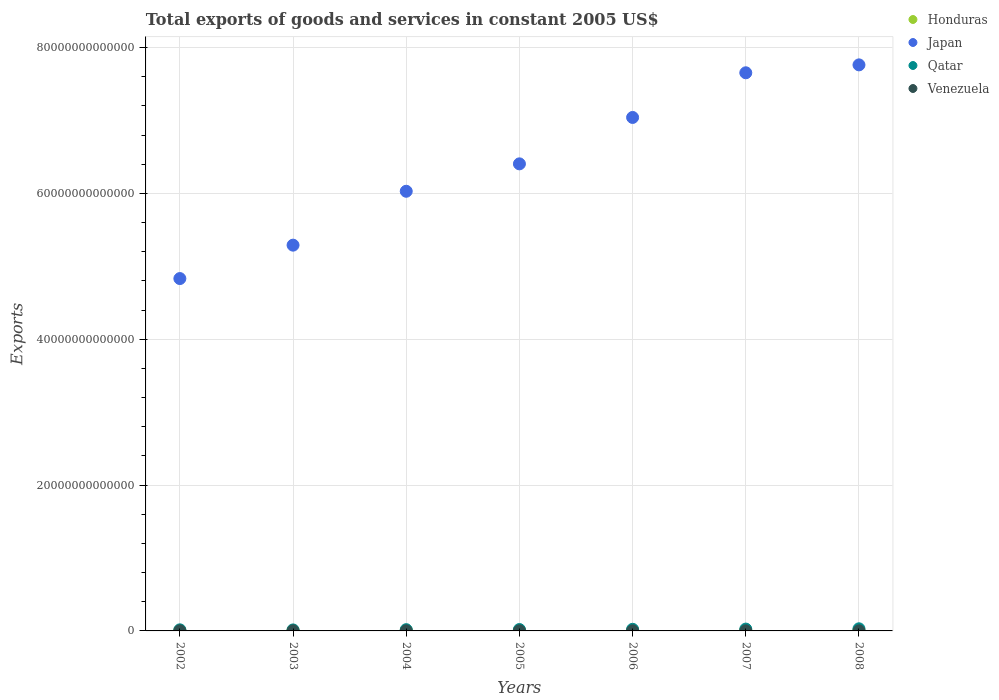What is the total exports of goods and services in Qatar in 2004?
Offer a very short reply. 1.72e+11. Across all years, what is the maximum total exports of goods and services in Japan?
Offer a very short reply. 7.76e+13. Across all years, what is the minimum total exports of goods and services in Honduras?
Keep it short and to the point. 6.58e+1. In which year was the total exports of goods and services in Qatar maximum?
Offer a very short reply. 2008. In which year was the total exports of goods and services in Honduras minimum?
Provide a short and direct response. 2002. What is the total total exports of goods and services in Qatar in the graph?
Your answer should be compact. 1.41e+12. What is the difference between the total exports of goods and services in Qatar in 2005 and that in 2006?
Your response must be concise. -3.11e+1. What is the difference between the total exports of goods and services in Qatar in 2005 and the total exports of goods and services in Venezuela in 2007?
Keep it short and to the point. 1.80e+11. What is the average total exports of goods and services in Qatar per year?
Make the answer very short. 2.02e+11. In the year 2006, what is the difference between the total exports of goods and services in Venezuela and total exports of goods and services in Japan?
Make the answer very short. -7.04e+13. What is the ratio of the total exports of goods and services in Venezuela in 2002 to that in 2005?
Keep it short and to the point. 0.95. What is the difference between the highest and the second highest total exports of goods and services in Honduras?
Give a very brief answer. 7.64e+08. What is the difference between the highest and the lowest total exports of goods and services in Japan?
Your response must be concise. 2.93e+13. Is the sum of the total exports of goods and services in Honduras in 2002 and 2005 greater than the maximum total exports of goods and services in Qatar across all years?
Give a very brief answer. No. How many dotlines are there?
Your answer should be very brief. 4. What is the difference between two consecutive major ticks on the Y-axis?
Offer a very short reply. 2.00e+13. Are the values on the major ticks of Y-axis written in scientific E-notation?
Give a very brief answer. No. Does the graph contain grids?
Provide a short and direct response. Yes. How many legend labels are there?
Ensure brevity in your answer.  4. What is the title of the graph?
Make the answer very short. Total exports of goods and services in constant 2005 US$. Does "Lebanon" appear as one of the legend labels in the graph?
Offer a very short reply. No. What is the label or title of the X-axis?
Offer a very short reply. Years. What is the label or title of the Y-axis?
Keep it short and to the point. Exports. What is the Exports in Honduras in 2002?
Provide a short and direct response. 6.58e+1. What is the Exports of Japan in 2002?
Ensure brevity in your answer.  4.83e+13. What is the Exports in Qatar in 2002?
Give a very brief answer. 1.49e+11. What is the Exports of Venezuela in 2002?
Give a very brief answer. 1.11e+1. What is the Exports of Honduras in 2003?
Give a very brief answer. 7.16e+1. What is the Exports of Japan in 2003?
Offer a terse response. 5.29e+13. What is the Exports in Qatar in 2003?
Provide a succinct answer. 1.37e+11. What is the Exports in Venezuela in 2003?
Ensure brevity in your answer.  9.94e+09. What is the Exports in Honduras in 2004?
Your answer should be compact. 8.10e+1. What is the Exports in Japan in 2004?
Your answer should be compact. 6.03e+13. What is the Exports in Qatar in 2004?
Keep it short and to the point. 1.72e+11. What is the Exports in Venezuela in 2004?
Provide a short and direct response. 1.13e+1. What is the Exports in Honduras in 2005?
Your answer should be very brief. 8.53e+1. What is the Exports of Japan in 2005?
Provide a succinct answer. 6.41e+13. What is the Exports of Qatar in 2005?
Your answer should be very brief. 1.90e+11. What is the Exports in Venezuela in 2005?
Offer a terse response. 1.17e+1. What is the Exports in Honduras in 2006?
Make the answer very short. 8.67e+1. What is the Exports of Japan in 2006?
Offer a terse response. 7.04e+13. What is the Exports in Qatar in 2006?
Your answer should be very brief. 2.21e+11. What is the Exports of Venezuela in 2006?
Offer a terse response. 1.14e+1. What is the Exports of Honduras in 2007?
Keep it short and to the point. 8.89e+1. What is the Exports in Japan in 2007?
Your response must be concise. 7.65e+13. What is the Exports of Qatar in 2007?
Your answer should be compact. 2.52e+11. What is the Exports in Venezuela in 2007?
Offer a terse response. 1.05e+1. What is the Exports of Honduras in 2008?
Offer a terse response. 8.96e+1. What is the Exports of Japan in 2008?
Make the answer very short. 7.76e+13. What is the Exports of Qatar in 2008?
Give a very brief answer. 2.91e+11. What is the Exports in Venezuela in 2008?
Your answer should be very brief. 1.04e+1. Across all years, what is the maximum Exports of Honduras?
Give a very brief answer. 8.96e+1. Across all years, what is the maximum Exports in Japan?
Your answer should be compact. 7.76e+13. Across all years, what is the maximum Exports of Qatar?
Your answer should be compact. 2.91e+11. Across all years, what is the maximum Exports of Venezuela?
Offer a terse response. 1.17e+1. Across all years, what is the minimum Exports of Honduras?
Your response must be concise. 6.58e+1. Across all years, what is the minimum Exports in Japan?
Offer a very short reply. 4.83e+13. Across all years, what is the minimum Exports of Qatar?
Your response must be concise. 1.37e+11. Across all years, what is the minimum Exports in Venezuela?
Offer a very short reply. 9.94e+09. What is the total Exports in Honduras in the graph?
Provide a short and direct response. 5.69e+11. What is the total Exports in Japan in the graph?
Your answer should be compact. 4.50e+14. What is the total Exports in Qatar in the graph?
Your response must be concise. 1.41e+12. What is the total Exports in Venezuela in the graph?
Your answer should be very brief. 7.63e+1. What is the difference between the Exports in Honduras in 2002 and that in 2003?
Provide a succinct answer. -5.75e+09. What is the difference between the Exports in Japan in 2002 and that in 2003?
Offer a very short reply. -4.58e+12. What is the difference between the Exports in Qatar in 2002 and that in 2003?
Your answer should be very brief. 1.24e+1. What is the difference between the Exports of Venezuela in 2002 and that in 2003?
Your response must be concise. 1.15e+09. What is the difference between the Exports of Honduras in 2002 and that in 2004?
Offer a terse response. -1.52e+1. What is the difference between the Exports of Japan in 2002 and that in 2004?
Keep it short and to the point. -1.20e+13. What is the difference between the Exports of Qatar in 2002 and that in 2004?
Offer a very short reply. -2.31e+1. What is the difference between the Exports of Venezuela in 2002 and that in 2004?
Offer a terse response. -2.09e+08. What is the difference between the Exports of Honduras in 2002 and that in 2005?
Give a very brief answer. -1.95e+1. What is the difference between the Exports in Japan in 2002 and that in 2005?
Keep it short and to the point. -1.57e+13. What is the difference between the Exports in Qatar in 2002 and that in 2005?
Your answer should be very brief. -4.10e+1. What is the difference between the Exports of Venezuela in 2002 and that in 2005?
Offer a very short reply. -6.34e+08. What is the difference between the Exports in Honduras in 2002 and that in 2006?
Ensure brevity in your answer.  -2.08e+1. What is the difference between the Exports of Japan in 2002 and that in 2006?
Give a very brief answer. -2.21e+13. What is the difference between the Exports in Qatar in 2002 and that in 2006?
Offer a terse response. -7.21e+1. What is the difference between the Exports of Venezuela in 2002 and that in 2006?
Provide a succinct answer. -2.81e+08. What is the difference between the Exports in Honduras in 2002 and that in 2007?
Provide a short and direct response. -2.30e+1. What is the difference between the Exports of Japan in 2002 and that in 2007?
Make the answer very short. -2.82e+13. What is the difference between the Exports in Qatar in 2002 and that in 2007?
Give a very brief answer. -1.03e+11. What is the difference between the Exports in Venezuela in 2002 and that in 2007?
Provide a succinct answer. 5.78e+08. What is the difference between the Exports of Honduras in 2002 and that in 2008?
Give a very brief answer. -2.38e+1. What is the difference between the Exports in Japan in 2002 and that in 2008?
Ensure brevity in your answer.  -2.93e+13. What is the difference between the Exports of Qatar in 2002 and that in 2008?
Your answer should be compact. -1.42e+11. What is the difference between the Exports of Venezuela in 2002 and that in 2008?
Make the answer very short. 6.81e+08. What is the difference between the Exports of Honduras in 2003 and that in 2004?
Offer a very short reply. -9.45e+09. What is the difference between the Exports in Japan in 2003 and that in 2004?
Offer a terse response. -7.39e+12. What is the difference between the Exports of Qatar in 2003 and that in 2004?
Keep it short and to the point. -3.55e+1. What is the difference between the Exports of Venezuela in 2003 and that in 2004?
Keep it short and to the point. -1.36e+09. What is the difference between the Exports of Honduras in 2003 and that in 2005?
Your response must be concise. -1.37e+1. What is the difference between the Exports in Japan in 2003 and that in 2005?
Your answer should be very brief. -1.12e+13. What is the difference between the Exports in Qatar in 2003 and that in 2005?
Your answer should be compact. -5.34e+1. What is the difference between the Exports in Venezuela in 2003 and that in 2005?
Keep it short and to the point. -1.79e+09. What is the difference between the Exports in Honduras in 2003 and that in 2006?
Provide a short and direct response. -1.51e+1. What is the difference between the Exports in Japan in 2003 and that in 2006?
Your answer should be compact. -1.75e+13. What is the difference between the Exports of Qatar in 2003 and that in 2006?
Your answer should be compact. -8.45e+1. What is the difference between the Exports in Venezuela in 2003 and that in 2006?
Your answer should be compact. -1.43e+09. What is the difference between the Exports in Honduras in 2003 and that in 2007?
Make the answer very short. -1.73e+1. What is the difference between the Exports in Japan in 2003 and that in 2007?
Give a very brief answer. -2.36e+13. What is the difference between the Exports of Qatar in 2003 and that in 2007?
Make the answer very short. -1.15e+11. What is the difference between the Exports in Venezuela in 2003 and that in 2007?
Provide a succinct answer. -5.73e+08. What is the difference between the Exports in Honduras in 2003 and that in 2008?
Your answer should be compact. -1.80e+1. What is the difference between the Exports in Japan in 2003 and that in 2008?
Your answer should be compact. -2.47e+13. What is the difference between the Exports of Qatar in 2003 and that in 2008?
Ensure brevity in your answer.  -1.54e+11. What is the difference between the Exports of Venezuela in 2003 and that in 2008?
Ensure brevity in your answer.  -4.70e+08. What is the difference between the Exports of Honduras in 2004 and that in 2005?
Your answer should be very brief. -4.30e+09. What is the difference between the Exports in Japan in 2004 and that in 2005?
Your answer should be very brief. -3.76e+12. What is the difference between the Exports of Qatar in 2004 and that in 2005?
Provide a succinct answer. -1.79e+1. What is the difference between the Exports of Venezuela in 2004 and that in 2005?
Make the answer very short. -4.26e+08. What is the difference between the Exports of Honduras in 2004 and that in 2006?
Provide a succinct answer. -5.63e+09. What is the difference between the Exports of Japan in 2004 and that in 2006?
Provide a short and direct response. -1.01e+13. What is the difference between the Exports in Qatar in 2004 and that in 2006?
Offer a terse response. -4.90e+1. What is the difference between the Exports of Venezuela in 2004 and that in 2006?
Provide a short and direct response. -7.21e+07. What is the difference between the Exports in Honduras in 2004 and that in 2007?
Your response must be concise. -7.82e+09. What is the difference between the Exports of Japan in 2004 and that in 2007?
Provide a short and direct response. -1.62e+13. What is the difference between the Exports in Qatar in 2004 and that in 2007?
Your answer should be compact. -7.96e+1. What is the difference between the Exports in Venezuela in 2004 and that in 2007?
Provide a succinct answer. 7.86e+08. What is the difference between the Exports of Honduras in 2004 and that in 2008?
Your answer should be very brief. -8.59e+09. What is the difference between the Exports in Japan in 2004 and that in 2008?
Keep it short and to the point. -1.73e+13. What is the difference between the Exports of Qatar in 2004 and that in 2008?
Make the answer very short. -1.18e+11. What is the difference between the Exports of Venezuela in 2004 and that in 2008?
Your response must be concise. 8.90e+08. What is the difference between the Exports of Honduras in 2005 and that in 2006?
Provide a short and direct response. -1.33e+09. What is the difference between the Exports of Japan in 2005 and that in 2006?
Your response must be concise. -6.36e+12. What is the difference between the Exports in Qatar in 2005 and that in 2006?
Your answer should be very brief. -3.11e+1. What is the difference between the Exports in Venezuela in 2005 and that in 2006?
Your answer should be compact. 3.54e+08. What is the difference between the Exports in Honduras in 2005 and that in 2007?
Offer a terse response. -3.52e+09. What is the difference between the Exports in Japan in 2005 and that in 2007?
Your answer should be very brief. -1.25e+13. What is the difference between the Exports of Qatar in 2005 and that in 2007?
Your answer should be compact. -6.18e+1. What is the difference between the Exports of Venezuela in 2005 and that in 2007?
Offer a terse response. 1.21e+09. What is the difference between the Exports of Honduras in 2005 and that in 2008?
Offer a very short reply. -4.29e+09. What is the difference between the Exports of Japan in 2005 and that in 2008?
Offer a terse response. -1.36e+13. What is the difference between the Exports in Qatar in 2005 and that in 2008?
Keep it short and to the point. -1.01e+11. What is the difference between the Exports in Venezuela in 2005 and that in 2008?
Your answer should be very brief. 1.32e+09. What is the difference between the Exports in Honduras in 2006 and that in 2007?
Make the answer very short. -2.20e+09. What is the difference between the Exports of Japan in 2006 and that in 2007?
Make the answer very short. -6.13e+12. What is the difference between the Exports in Qatar in 2006 and that in 2007?
Your response must be concise. -3.06e+1. What is the difference between the Exports of Venezuela in 2006 and that in 2007?
Provide a succinct answer. 8.58e+08. What is the difference between the Exports in Honduras in 2006 and that in 2008?
Your response must be concise. -2.96e+09. What is the difference between the Exports in Japan in 2006 and that in 2008?
Make the answer very short. -7.21e+12. What is the difference between the Exports in Qatar in 2006 and that in 2008?
Offer a very short reply. -6.95e+1. What is the difference between the Exports in Venezuela in 2006 and that in 2008?
Ensure brevity in your answer.  9.62e+08. What is the difference between the Exports in Honduras in 2007 and that in 2008?
Offer a very short reply. -7.64e+08. What is the difference between the Exports in Japan in 2007 and that in 2008?
Provide a short and direct response. -1.08e+12. What is the difference between the Exports of Qatar in 2007 and that in 2008?
Your response must be concise. -3.88e+1. What is the difference between the Exports in Venezuela in 2007 and that in 2008?
Give a very brief answer. 1.03e+08. What is the difference between the Exports of Honduras in 2002 and the Exports of Japan in 2003?
Your answer should be very brief. -5.28e+13. What is the difference between the Exports of Honduras in 2002 and the Exports of Qatar in 2003?
Your answer should be very brief. -7.09e+1. What is the difference between the Exports in Honduras in 2002 and the Exports in Venezuela in 2003?
Give a very brief answer. 5.59e+1. What is the difference between the Exports in Japan in 2002 and the Exports in Qatar in 2003?
Keep it short and to the point. 4.82e+13. What is the difference between the Exports in Japan in 2002 and the Exports in Venezuela in 2003?
Give a very brief answer. 4.83e+13. What is the difference between the Exports in Qatar in 2002 and the Exports in Venezuela in 2003?
Ensure brevity in your answer.  1.39e+11. What is the difference between the Exports of Honduras in 2002 and the Exports of Japan in 2004?
Offer a very short reply. -6.02e+13. What is the difference between the Exports in Honduras in 2002 and the Exports in Qatar in 2004?
Offer a terse response. -1.06e+11. What is the difference between the Exports in Honduras in 2002 and the Exports in Venezuela in 2004?
Provide a succinct answer. 5.45e+1. What is the difference between the Exports of Japan in 2002 and the Exports of Qatar in 2004?
Your answer should be very brief. 4.82e+13. What is the difference between the Exports of Japan in 2002 and the Exports of Venezuela in 2004?
Offer a very short reply. 4.83e+13. What is the difference between the Exports in Qatar in 2002 and the Exports in Venezuela in 2004?
Provide a succinct answer. 1.38e+11. What is the difference between the Exports in Honduras in 2002 and the Exports in Japan in 2005?
Give a very brief answer. -6.40e+13. What is the difference between the Exports of Honduras in 2002 and the Exports of Qatar in 2005?
Your answer should be very brief. -1.24e+11. What is the difference between the Exports in Honduras in 2002 and the Exports in Venezuela in 2005?
Provide a succinct answer. 5.41e+1. What is the difference between the Exports in Japan in 2002 and the Exports in Qatar in 2005?
Your response must be concise. 4.81e+13. What is the difference between the Exports in Japan in 2002 and the Exports in Venezuela in 2005?
Your response must be concise. 4.83e+13. What is the difference between the Exports in Qatar in 2002 and the Exports in Venezuela in 2005?
Your response must be concise. 1.37e+11. What is the difference between the Exports of Honduras in 2002 and the Exports of Japan in 2006?
Give a very brief answer. -7.04e+13. What is the difference between the Exports of Honduras in 2002 and the Exports of Qatar in 2006?
Provide a short and direct response. -1.55e+11. What is the difference between the Exports in Honduras in 2002 and the Exports in Venezuela in 2006?
Ensure brevity in your answer.  5.45e+1. What is the difference between the Exports of Japan in 2002 and the Exports of Qatar in 2006?
Provide a succinct answer. 4.81e+13. What is the difference between the Exports in Japan in 2002 and the Exports in Venezuela in 2006?
Ensure brevity in your answer.  4.83e+13. What is the difference between the Exports in Qatar in 2002 and the Exports in Venezuela in 2006?
Your answer should be very brief. 1.38e+11. What is the difference between the Exports in Honduras in 2002 and the Exports in Japan in 2007?
Provide a succinct answer. -7.65e+13. What is the difference between the Exports in Honduras in 2002 and the Exports in Qatar in 2007?
Keep it short and to the point. -1.86e+11. What is the difference between the Exports in Honduras in 2002 and the Exports in Venezuela in 2007?
Give a very brief answer. 5.53e+1. What is the difference between the Exports in Japan in 2002 and the Exports in Qatar in 2007?
Offer a very short reply. 4.81e+13. What is the difference between the Exports in Japan in 2002 and the Exports in Venezuela in 2007?
Offer a terse response. 4.83e+13. What is the difference between the Exports in Qatar in 2002 and the Exports in Venezuela in 2007?
Provide a short and direct response. 1.39e+11. What is the difference between the Exports in Honduras in 2002 and the Exports in Japan in 2008?
Offer a terse response. -7.76e+13. What is the difference between the Exports in Honduras in 2002 and the Exports in Qatar in 2008?
Make the answer very short. -2.25e+11. What is the difference between the Exports of Honduras in 2002 and the Exports of Venezuela in 2008?
Your answer should be compact. 5.54e+1. What is the difference between the Exports of Japan in 2002 and the Exports of Qatar in 2008?
Offer a terse response. 4.80e+13. What is the difference between the Exports of Japan in 2002 and the Exports of Venezuela in 2008?
Offer a very short reply. 4.83e+13. What is the difference between the Exports of Qatar in 2002 and the Exports of Venezuela in 2008?
Give a very brief answer. 1.39e+11. What is the difference between the Exports in Honduras in 2003 and the Exports in Japan in 2004?
Provide a succinct answer. -6.02e+13. What is the difference between the Exports of Honduras in 2003 and the Exports of Qatar in 2004?
Your answer should be compact. -1.01e+11. What is the difference between the Exports of Honduras in 2003 and the Exports of Venezuela in 2004?
Keep it short and to the point. 6.03e+1. What is the difference between the Exports in Japan in 2003 and the Exports in Qatar in 2004?
Offer a terse response. 5.27e+13. What is the difference between the Exports in Japan in 2003 and the Exports in Venezuela in 2004?
Make the answer very short. 5.29e+13. What is the difference between the Exports in Qatar in 2003 and the Exports in Venezuela in 2004?
Offer a terse response. 1.25e+11. What is the difference between the Exports in Honduras in 2003 and the Exports in Japan in 2005?
Offer a terse response. -6.40e+13. What is the difference between the Exports of Honduras in 2003 and the Exports of Qatar in 2005?
Your answer should be compact. -1.19e+11. What is the difference between the Exports in Honduras in 2003 and the Exports in Venezuela in 2005?
Offer a terse response. 5.99e+1. What is the difference between the Exports of Japan in 2003 and the Exports of Qatar in 2005?
Make the answer very short. 5.27e+13. What is the difference between the Exports of Japan in 2003 and the Exports of Venezuela in 2005?
Offer a very short reply. 5.29e+13. What is the difference between the Exports in Qatar in 2003 and the Exports in Venezuela in 2005?
Ensure brevity in your answer.  1.25e+11. What is the difference between the Exports of Honduras in 2003 and the Exports of Japan in 2006?
Provide a succinct answer. -7.03e+13. What is the difference between the Exports in Honduras in 2003 and the Exports in Qatar in 2006?
Your response must be concise. -1.50e+11. What is the difference between the Exports of Honduras in 2003 and the Exports of Venezuela in 2006?
Ensure brevity in your answer.  6.02e+1. What is the difference between the Exports of Japan in 2003 and the Exports of Qatar in 2006?
Keep it short and to the point. 5.27e+13. What is the difference between the Exports in Japan in 2003 and the Exports in Venezuela in 2006?
Ensure brevity in your answer.  5.29e+13. What is the difference between the Exports of Qatar in 2003 and the Exports of Venezuela in 2006?
Offer a terse response. 1.25e+11. What is the difference between the Exports in Honduras in 2003 and the Exports in Japan in 2007?
Offer a very short reply. -7.65e+13. What is the difference between the Exports in Honduras in 2003 and the Exports in Qatar in 2007?
Give a very brief answer. -1.80e+11. What is the difference between the Exports in Honduras in 2003 and the Exports in Venezuela in 2007?
Make the answer very short. 6.11e+1. What is the difference between the Exports of Japan in 2003 and the Exports of Qatar in 2007?
Provide a succinct answer. 5.27e+13. What is the difference between the Exports of Japan in 2003 and the Exports of Venezuela in 2007?
Your response must be concise. 5.29e+13. What is the difference between the Exports of Qatar in 2003 and the Exports of Venezuela in 2007?
Give a very brief answer. 1.26e+11. What is the difference between the Exports in Honduras in 2003 and the Exports in Japan in 2008?
Your answer should be compact. -7.76e+13. What is the difference between the Exports of Honduras in 2003 and the Exports of Qatar in 2008?
Provide a short and direct response. -2.19e+11. What is the difference between the Exports of Honduras in 2003 and the Exports of Venezuela in 2008?
Provide a short and direct response. 6.12e+1. What is the difference between the Exports of Japan in 2003 and the Exports of Qatar in 2008?
Your answer should be compact. 5.26e+13. What is the difference between the Exports of Japan in 2003 and the Exports of Venezuela in 2008?
Give a very brief answer. 5.29e+13. What is the difference between the Exports of Qatar in 2003 and the Exports of Venezuela in 2008?
Provide a succinct answer. 1.26e+11. What is the difference between the Exports in Honduras in 2004 and the Exports in Japan in 2005?
Your answer should be very brief. -6.40e+13. What is the difference between the Exports in Honduras in 2004 and the Exports in Qatar in 2005?
Your response must be concise. -1.09e+11. What is the difference between the Exports in Honduras in 2004 and the Exports in Venezuela in 2005?
Provide a short and direct response. 6.93e+1. What is the difference between the Exports of Japan in 2004 and the Exports of Qatar in 2005?
Offer a very short reply. 6.01e+13. What is the difference between the Exports in Japan in 2004 and the Exports in Venezuela in 2005?
Ensure brevity in your answer.  6.03e+13. What is the difference between the Exports in Qatar in 2004 and the Exports in Venezuela in 2005?
Ensure brevity in your answer.  1.61e+11. What is the difference between the Exports of Honduras in 2004 and the Exports of Japan in 2006?
Provide a succinct answer. -7.03e+13. What is the difference between the Exports in Honduras in 2004 and the Exports in Qatar in 2006?
Your answer should be compact. -1.40e+11. What is the difference between the Exports of Honduras in 2004 and the Exports of Venezuela in 2006?
Keep it short and to the point. 6.97e+1. What is the difference between the Exports in Japan in 2004 and the Exports in Qatar in 2006?
Provide a succinct answer. 6.01e+13. What is the difference between the Exports of Japan in 2004 and the Exports of Venezuela in 2006?
Provide a short and direct response. 6.03e+13. What is the difference between the Exports of Qatar in 2004 and the Exports of Venezuela in 2006?
Offer a terse response. 1.61e+11. What is the difference between the Exports of Honduras in 2004 and the Exports of Japan in 2007?
Keep it short and to the point. -7.65e+13. What is the difference between the Exports in Honduras in 2004 and the Exports in Qatar in 2007?
Your answer should be very brief. -1.71e+11. What is the difference between the Exports in Honduras in 2004 and the Exports in Venezuela in 2007?
Offer a terse response. 7.05e+1. What is the difference between the Exports in Japan in 2004 and the Exports in Qatar in 2007?
Your response must be concise. 6.00e+13. What is the difference between the Exports in Japan in 2004 and the Exports in Venezuela in 2007?
Keep it short and to the point. 6.03e+13. What is the difference between the Exports of Qatar in 2004 and the Exports of Venezuela in 2007?
Your answer should be very brief. 1.62e+11. What is the difference between the Exports in Honduras in 2004 and the Exports in Japan in 2008?
Your answer should be very brief. -7.75e+13. What is the difference between the Exports in Honduras in 2004 and the Exports in Qatar in 2008?
Give a very brief answer. -2.10e+11. What is the difference between the Exports in Honduras in 2004 and the Exports in Venezuela in 2008?
Provide a short and direct response. 7.06e+1. What is the difference between the Exports in Japan in 2004 and the Exports in Qatar in 2008?
Offer a very short reply. 6.00e+13. What is the difference between the Exports in Japan in 2004 and the Exports in Venezuela in 2008?
Provide a short and direct response. 6.03e+13. What is the difference between the Exports of Qatar in 2004 and the Exports of Venezuela in 2008?
Your response must be concise. 1.62e+11. What is the difference between the Exports in Honduras in 2005 and the Exports in Japan in 2006?
Your response must be concise. -7.03e+13. What is the difference between the Exports of Honduras in 2005 and the Exports of Qatar in 2006?
Provide a succinct answer. -1.36e+11. What is the difference between the Exports of Honduras in 2005 and the Exports of Venezuela in 2006?
Your answer should be compact. 7.40e+1. What is the difference between the Exports of Japan in 2005 and the Exports of Qatar in 2006?
Your answer should be very brief. 6.38e+13. What is the difference between the Exports of Japan in 2005 and the Exports of Venezuela in 2006?
Provide a short and direct response. 6.40e+13. What is the difference between the Exports of Qatar in 2005 and the Exports of Venezuela in 2006?
Give a very brief answer. 1.79e+11. What is the difference between the Exports in Honduras in 2005 and the Exports in Japan in 2007?
Make the answer very short. -7.65e+13. What is the difference between the Exports of Honduras in 2005 and the Exports of Qatar in 2007?
Provide a short and direct response. -1.67e+11. What is the difference between the Exports in Honduras in 2005 and the Exports in Venezuela in 2007?
Your answer should be very brief. 7.48e+1. What is the difference between the Exports of Japan in 2005 and the Exports of Qatar in 2007?
Keep it short and to the point. 6.38e+13. What is the difference between the Exports of Japan in 2005 and the Exports of Venezuela in 2007?
Make the answer very short. 6.40e+13. What is the difference between the Exports of Qatar in 2005 and the Exports of Venezuela in 2007?
Your answer should be very brief. 1.80e+11. What is the difference between the Exports in Honduras in 2005 and the Exports in Japan in 2008?
Your answer should be very brief. -7.75e+13. What is the difference between the Exports of Honduras in 2005 and the Exports of Qatar in 2008?
Your answer should be very brief. -2.05e+11. What is the difference between the Exports in Honduras in 2005 and the Exports in Venezuela in 2008?
Your answer should be compact. 7.49e+1. What is the difference between the Exports in Japan in 2005 and the Exports in Qatar in 2008?
Provide a succinct answer. 6.38e+13. What is the difference between the Exports of Japan in 2005 and the Exports of Venezuela in 2008?
Your response must be concise. 6.40e+13. What is the difference between the Exports of Qatar in 2005 and the Exports of Venezuela in 2008?
Your answer should be compact. 1.80e+11. What is the difference between the Exports in Honduras in 2006 and the Exports in Japan in 2007?
Keep it short and to the point. -7.65e+13. What is the difference between the Exports in Honduras in 2006 and the Exports in Qatar in 2007?
Your response must be concise. -1.65e+11. What is the difference between the Exports in Honduras in 2006 and the Exports in Venezuela in 2007?
Your answer should be compact. 7.61e+1. What is the difference between the Exports of Japan in 2006 and the Exports of Qatar in 2007?
Offer a very short reply. 7.02e+13. What is the difference between the Exports of Japan in 2006 and the Exports of Venezuela in 2007?
Provide a succinct answer. 7.04e+13. What is the difference between the Exports in Qatar in 2006 and the Exports in Venezuela in 2007?
Your response must be concise. 2.11e+11. What is the difference between the Exports in Honduras in 2006 and the Exports in Japan in 2008?
Offer a very short reply. -7.75e+13. What is the difference between the Exports of Honduras in 2006 and the Exports of Qatar in 2008?
Provide a succinct answer. -2.04e+11. What is the difference between the Exports in Honduras in 2006 and the Exports in Venezuela in 2008?
Offer a very short reply. 7.62e+1. What is the difference between the Exports in Japan in 2006 and the Exports in Qatar in 2008?
Your response must be concise. 7.01e+13. What is the difference between the Exports in Japan in 2006 and the Exports in Venezuela in 2008?
Give a very brief answer. 7.04e+13. What is the difference between the Exports in Qatar in 2006 and the Exports in Venezuela in 2008?
Your answer should be very brief. 2.11e+11. What is the difference between the Exports in Honduras in 2007 and the Exports in Japan in 2008?
Make the answer very short. -7.75e+13. What is the difference between the Exports of Honduras in 2007 and the Exports of Qatar in 2008?
Provide a short and direct response. -2.02e+11. What is the difference between the Exports in Honduras in 2007 and the Exports in Venezuela in 2008?
Keep it short and to the point. 7.84e+1. What is the difference between the Exports of Japan in 2007 and the Exports of Qatar in 2008?
Your response must be concise. 7.63e+13. What is the difference between the Exports of Japan in 2007 and the Exports of Venezuela in 2008?
Offer a terse response. 7.65e+13. What is the difference between the Exports of Qatar in 2007 and the Exports of Venezuela in 2008?
Offer a terse response. 2.42e+11. What is the average Exports in Honduras per year?
Make the answer very short. 8.13e+1. What is the average Exports of Japan per year?
Offer a terse response. 6.43e+13. What is the average Exports of Qatar per year?
Your response must be concise. 2.02e+11. What is the average Exports in Venezuela per year?
Give a very brief answer. 1.09e+1. In the year 2002, what is the difference between the Exports of Honduras and Exports of Japan?
Provide a short and direct response. -4.83e+13. In the year 2002, what is the difference between the Exports in Honduras and Exports in Qatar?
Make the answer very short. -8.33e+1. In the year 2002, what is the difference between the Exports in Honduras and Exports in Venezuela?
Keep it short and to the point. 5.47e+1. In the year 2002, what is the difference between the Exports in Japan and Exports in Qatar?
Your answer should be very brief. 4.82e+13. In the year 2002, what is the difference between the Exports of Japan and Exports of Venezuela?
Your answer should be compact. 4.83e+13. In the year 2002, what is the difference between the Exports in Qatar and Exports in Venezuela?
Your response must be concise. 1.38e+11. In the year 2003, what is the difference between the Exports of Honduras and Exports of Japan?
Keep it short and to the point. -5.28e+13. In the year 2003, what is the difference between the Exports in Honduras and Exports in Qatar?
Your response must be concise. -6.52e+1. In the year 2003, what is the difference between the Exports in Honduras and Exports in Venezuela?
Ensure brevity in your answer.  6.16e+1. In the year 2003, what is the difference between the Exports in Japan and Exports in Qatar?
Offer a terse response. 5.28e+13. In the year 2003, what is the difference between the Exports in Japan and Exports in Venezuela?
Your answer should be compact. 5.29e+13. In the year 2003, what is the difference between the Exports in Qatar and Exports in Venezuela?
Your answer should be very brief. 1.27e+11. In the year 2004, what is the difference between the Exports in Honduras and Exports in Japan?
Provide a succinct answer. -6.02e+13. In the year 2004, what is the difference between the Exports of Honduras and Exports of Qatar?
Give a very brief answer. -9.13e+1. In the year 2004, what is the difference between the Exports in Honduras and Exports in Venezuela?
Give a very brief answer. 6.97e+1. In the year 2004, what is the difference between the Exports in Japan and Exports in Qatar?
Keep it short and to the point. 6.01e+13. In the year 2004, what is the difference between the Exports of Japan and Exports of Venezuela?
Provide a short and direct response. 6.03e+13. In the year 2004, what is the difference between the Exports of Qatar and Exports of Venezuela?
Provide a short and direct response. 1.61e+11. In the year 2005, what is the difference between the Exports of Honduras and Exports of Japan?
Your answer should be very brief. -6.40e+13. In the year 2005, what is the difference between the Exports in Honduras and Exports in Qatar?
Offer a terse response. -1.05e+11. In the year 2005, what is the difference between the Exports in Honduras and Exports in Venezuela?
Keep it short and to the point. 7.36e+1. In the year 2005, what is the difference between the Exports of Japan and Exports of Qatar?
Offer a terse response. 6.39e+13. In the year 2005, what is the difference between the Exports in Japan and Exports in Venezuela?
Offer a very short reply. 6.40e+13. In the year 2005, what is the difference between the Exports in Qatar and Exports in Venezuela?
Give a very brief answer. 1.78e+11. In the year 2006, what is the difference between the Exports in Honduras and Exports in Japan?
Your answer should be very brief. -7.03e+13. In the year 2006, what is the difference between the Exports of Honduras and Exports of Qatar?
Provide a succinct answer. -1.35e+11. In the year 2006, what is the difference between the Exports of Honduras and Exports of Venezuela?
Your answer should be very brief. 7.53e+1. In the year 2006, what is the difference between the Exports in Japan and Exports in Qatar?
Keep it short and to the point. 7.02e+13. In the year 2006, what is the difference between the Exports of Japan and Exports of Venezuela?
Ensure brevity in your answer.  7.04e+13. In the year 2006, what is the difference between the Exports in Qatar and Exports in Venezuela?
Your answer should be compact. 2.10e+11. In the year 2007, what is the difference between the Exports in Honduras and Exports in Japan?
Make the answer very short. -7.65e+13. In the year 2007, what is the difference between the Exports of Honduras and Exports of Qatar?
Ensure brevity in your answer.  -1.63e+11. In the year 2007, what is the difference between the Exports of Honduras and Exports of Venezuela?
Provide a succinct answer. 7.83e+1. In the year 2007, what is the difference between the Exports in Japan and Exports in Qatar?
Your answer should be compact. 7.63e+13. In the year 2007, what is the difference between the Exports in Japan and Exports in Venezuela?
Provide a succinct answer. 7.65e+13. In the year 2007, what is the difference between the Exports in Qatar and Exports in Venezuela?
Provide a succinct answer. 2.41e+11. In the year 2008, what is the difference between the Exports of Honduras and Exports of Japan?
Your answer should be compact. -7.75e+13. In the year 2008, what is the difference between the Exports of Honduras and Exports of Qatar?
Offer a terse response. -2.01e+11. In the year 2008, what is the difference between the Exports of Honduras and Exports of Venezuela?
Your answer should be compact. 7.92e+1. In the year 2008, what is the difference between the Exports in Japan and Exports in Qatar?
Your answer should be compact. 7.73e+13. In the year 2008, what is the difference between the Exports of Japan and Exports of Venezuela?
Your response must be concise. 7.76e+13. In the year 2008, what is the difference between the Exports in Qatar and Exports in Venezuela?
Provide a succinct answer. 2.80e+11. What is the ratio of the Exports in Honduras in 2002 to that in 2003?
Keep it short and to the point. 0.92. What is the ratio of the Exports of Japan in 2002 to that in 2003?
Your answer should be very brief. 0.91. What is the ratio of the Exports in Qatar in 2002 to that in 2003?
Provide a short and direct response. 1.09. What is the ratio of the Exports of Venezuela in 2002 to that in 2003?
Keep it short and to the point. 1.12. What is the ratio of the Exports of Honduras in 2002 to that in 2004?
Keep it short and to the point. 0.81. What is the ratio of the Exports in Japan in 2002 to that in 2004?
Your answer should be compact. 0.8. What is the ratio of the Exports in Qatar in 2002 to that in 2004?
Provide a short and direct response. 0.87. What is the ratio of the Exports in Venezuela in 2002 to that in 2004?
Make the answer very short. 0.98. What is the ratio of the Exports of Honduras in 2002 to that in 2005?
Provide a succinct answer. 0.77. What is the ratio of the Exports in Japan in 2002 to that in 2005?
Provide a short and direct response. 0.75. What is the ratio of the Exports of Qatar in 2002 to that in 2005?
Ensure brevity in your answer.  0.78. What is the ratio of the Exports of Venezuela in 2002 to that in 2005?
Provide a short and direct response. 0.95. What is the ratio of the Exports in Honduras in 2002 to that in 2006?
Give a very brief answer. 0.76. What is the ratio of the Exports of Japan in 2002 to that in 2006?
Give a very brief answer. 0.69. What is the ratio of the Exports of Qatar in 2002 to that in 2006?
Provide a short and direct response. 0.67. What is the ratio of the Exports in Venezuela in 2002 to that in 2006?
Ensure brevity in your answer.  0.98. What is the ratio of the Exports in Honduras in 2002 to that in 2007?
Provide a short and direct response. 0.74. What is the ratio of the Exports in Japan in 2002 to that in 2007?
Provide a short and direct response. 0.63. What is the ratio of the Exports in Qatar in 2002 to that in 2007?
Your answer should be compact. 0.59. What is the ratio of the Exports in Venezuela in 2002 to that in 2007?
Your response must be concise. 1.05. What is the ratio of the Exports of Honduras in 2002 to that in 2008?
Ensure brevity in your answer.  0.73. What is the ratio of the Exports in Japan in 2002 to that in 2008?
Provide a succinct answer. 0.62. What is the ratio of the Exports of Qatar in 2002 to that in 2008?
Offer a very short reply. 0.51. What is the ratio of the Exports in Venezuela in 2002 to that in 2008?
Your answer should be very brief. 1.07. What is the ratio of the Exports in Honduras in 2003 to that in 2004?
Make the answer very short. 0.88. What is the ratio of the Exports of Japan in 2003 to that in 2004?
Make the answer very short. 0.88. What is the ratio of the Exports of Qatar in 2003 to that in 2004?
Provide a short and direct response. 0.79. What is the ratio of the Exports of Venezuela in 2003 to that in 2004?
Your answer should be compact. 0.88. What is the ratio of the Exports of Honduras in 2003 to that in 2005?
Provide a short and direct response. 0.84. What is the ratio of the Exports of Japan in 2003 to that in 2005?
Ensure brevity in your answer.  0.83. What is the ratio of the Exports of Qatar in 2003 to that in 2005?
Provide a short and direct response. 0.72. What is the ratio of the Exports of Venezuela in 2003 to that in 2005?
Ensure brevity in your answer.  0.85. What is the ratio of the Exports in Honduras in 2003 to that in 2006?
Provide a succinct answer. 0.83. What is the ratio of the Exports of Japan in 2003 to that in 2006?
Ensure brevity in your answer.  0.75. What is the ratio of the Exports of Qatar in 2003 to that in 2006?
Offer a very short reply. 0.62. What is the ratio of the Exports of Venezuela in 2003 to that in 2006?
Ensure brevity in your answer.  0.87. What is the ratio of the Exports of Honduras in 2003 to that in 2007?
Offer a terse response. 0.81. What is the ratio of the Exports in Japan in 2003 to that in 2007?
Keep it short and to the point. 0.69. What is the ratio of the Exports in Qatar in 2003 to that in 2007?
Ensure brevity in your answer.  0.54. What is the ratio of the Exports of Venezuela in 2003 to that in 2007?
Offer a very short reply. 0.95. What is the ratio of the Exports in Honduras in 2003 to that in 2008?
Provide a short and direct response. 0.8. What is the ratio of the Exports in Japan in 2003 to that in 2008?
Give a very brief answer. 0.68. What is the ratio of the Exports of Qatar in 2003 to that in 2008?
Make the answer very short. 0.47. What is the ratio of the Exports of Venezuela in 2003 to that in 2008?
Make the answer very short. 0.95. What is the ratio of the Exports of Honduras in 2004 to that in 2005?
Your answer should be compact. 0.95. What is the ratio of the Exports in Japan in 2004 to that in 2005?
Provide a succinct answer. 0.94. What is the ratio of the Exports in Qatar in 2004 to that in 2005?
Offer a very short reply. 0.91. What is the ratio of the Exports of Venezuela in 2004 to that in 2005?
Provide a short and direct response. 0.96. What is the ratio of the Exports in Honduras in 2004 to that in 2006?
Your response must be concise. 0.94. What is the ratio of the Exports of Japan in 2004 to that in 2006?
Offer a very short reply. 0.86. What is the ratio of the Exports of Qatar in 2004 to that in 2006?
Your answer should be very brief. 0.78. What is the ratio of the Exports in Venezuela in 2004 to that in 2006?
Keep it short and to the point. 0.99. What is the ratio of the Exports in Honduras in 2004 to that in 2007?
Provide a short and direct response. 0.91. What is the ratio of the Exports of Japan in 2004 to that in 2007?
Make the answer very short. 0.79. What is the ratio of the Exports in Qatar in 2004 to that in 2007?
Offer a very short reply. 0.68. What is the ratio of the Exports in Venezuela in 2004 to that in 2007?
Ensure brevity in your answer.  1.07. What is the ratio of the Exports in Honduras in 2004 to that in 2008?
Ensure brevity in your answer.  0.9. What is the ratio of the Exports in Japan in 2004 to that in 2008?
Provide a succinct answer. 0.78. What is the ratio of the Exports in Qatar in 2004 to that in 2008?
Offer a terse response. 0.59. What is the ratio of the Exports of Venezuela in 2004 to that in 2008?
Offer a very short reply. 1.09. What is the ratio of the Exports in Honduras in 2005 to that in 2006?
Give a very brief answer. 0.98. What is the ratio of the Exports of Japan in 2005 to that in 2006?
Your answer should be very brief. 0.91. What is the ratio of the Exports in Qatar in 2005 to that in 2006?
Provide a succinct answer. 0.86. What is the ratio of the Exports in Venezuela in 2005 to that in 2006?
Ensure brevity in your answer.  1.03. What is the ratio of the Exports in Honduras in 2005 to that in 2007?
Offer a terse response. 0.96. What is the ratio of the Exports of Japan in 2005 to that in 2007?
Offer a very short reply. 0.84. What is the ratio of the Exports in Qatar in 2005 to that in 2007?
Keep it short and to the point. 0.75. What is the ratio of the Exports of Venezuela in 2005 to that in 2007?
Give a very brief answer. 1.12. What is the ratio of the Exports in Honduras in 2005 to that in 2008?
Provide a short and direct response. 0.95. What is the ratio of the Exports in Japan in 2005 to that in 2008?
Your answer should be compact. 0.83. What is the ratio of the Exports in Qatar in 2005 to that in 2008?
Ensure brevity in your answer.  0.65. What is the ratio of the Exports in Venezuela in 2005 to that in 2008?
Keep it short and to the point. 1.13. What is the ratio of the Exports of Honduras in 2006 to that in 2007?
Offer a terse response. 0.98. What is the ratio of the Exports of Japan in 2006 to that in 2007?
Offer a terse response. 0.92. What is the ratio of the Exports of Qatar in 2006 to that in 2007?
Make the answer very short. 0.88. What is the ratio of the Exports in Venezuela in 2006 to that in 2007?
Offer a terse response. 1.08. What is the ratio of the Exports of Honduras in 2006 to that in 2008?
Your answer should be compact. 0.97. What is the ratio of the Exports in Japan in 2006 to that in 2008?
Your response must be concise. 0.91. What is the ratio of the Exports of Qatar in 2006 to that in 2008?
Your answer should be compact. 0.76. What is the ratio of the Exports of Venezuela in 2006 to that in 2008?
Offer a terse response. 1.09. What is the ratio of the Exports of Honduras in 2007 to that in 2008?
Provide a short and direct response. 0.99. What is the ratio of the Exports of Japan in 2007 to that in 2008?
Your response must be concise. 0.99. What is the ratio of the Exports in Qatar in 2007 to that in 2008?
Ensure brevity in your answer.  0.87. What is the ratio of the Exports of Venezuela in 2007 to that in 2008?
Offer a very short reply. 1.01. What is the difference between the highest and the second highest Exports in Honduras?
Your response must be concise. 7.64e+08. What is the difference between the highest and the second highest Exports of Japan?
Offer a terse response. 1.08e+12. What is the difference between the highest and the second highest Exports in Qatar?
Provide a succinct answer. 3.88e+1. What is the difference between the highest and the second highest Exports in Venezuela?
Your response must be concise. 3.54e+08. What is the difference between the highest and the lowest Exports of Honduras?
Offer a terse response. 2.38e+1. What is the difference between the highest and the lowest Exports in Japan?
Provide a short and direct response. 2.93e+13. What is the difference between the highest and the lowest Exports of Qatar?
Keep it short and to the point. 1.54e+11. What is the difference between the highest and the lowest Exports in Venezuela?
Give a very brief answer. 1.79e+09. 